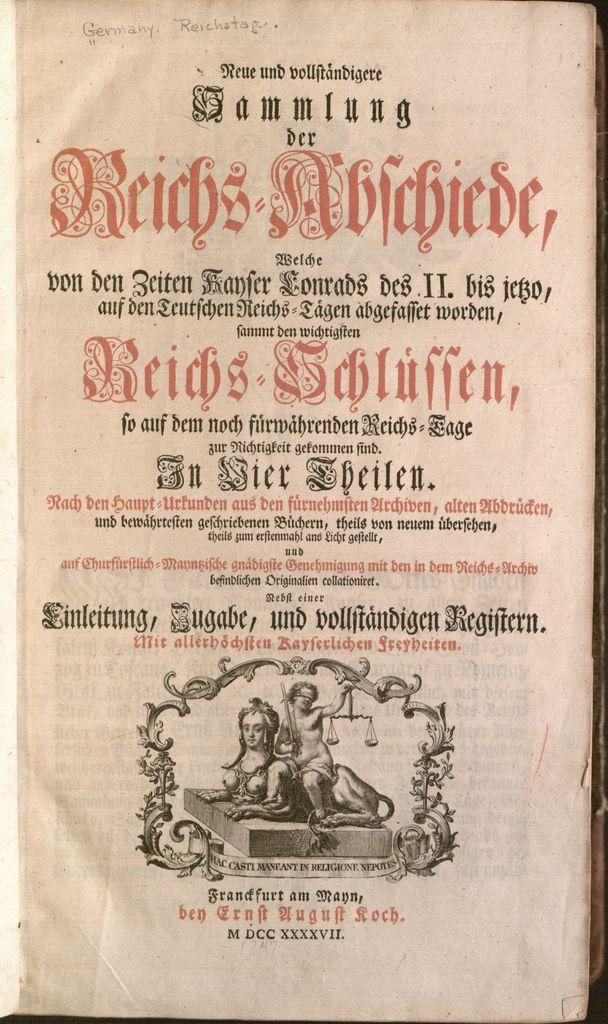What is depicted on the page from a book in the image? The page contains text and pictures. Can you describe the content of the page? The page contains text and pictures, which might be part of a story or educational material. Where is the mailbox located in the image? There is no mailbox present in the image. What type of sticks can be seen in the image? There are no sticks present in the image. What kind of toy is visible in the image? There is no toy present in the image. 